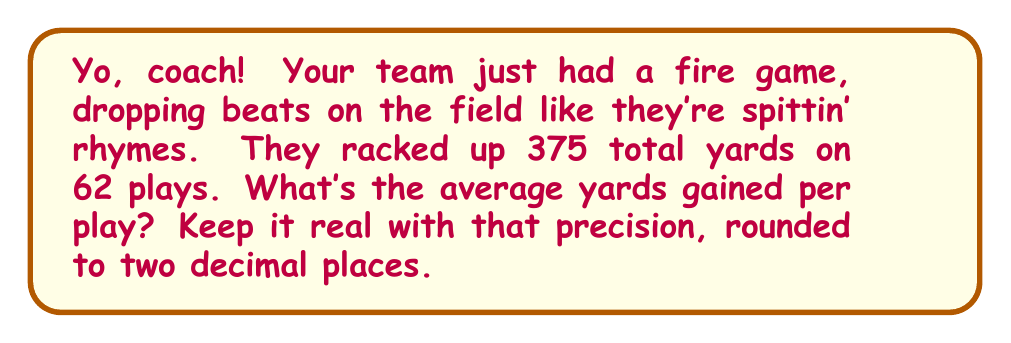Can you solve this math problem? Alright, let's break this down like we're analyzing a fresh track:

1) We've got two key stats here:
   - Total yards gained: 375
   - Number of plays: 62

2) To find the average yards per play, we need to divide the total yards by the number of plays. In mathematical terms:

   $$ \text{Average yards per play} = \frac{\text{Total yards}}{\text{Number of plays}} $$

3) Let's plug in our numbers:

   $$ \text{Average yards per play} = \frac{375}{62} $$

4) Now, let's do the division:

   $$ \frac{375}{62} \approx 6.0483870967741935 $$

5) The question asks for the answer rounded to two decimal places. To do this, we look at the third decimal place. If it's 5 or greater, we round up; if it's less than 5, we round down. In this case, the third decimal is 4, so we round down.

Therefore, rounded to two decimal places, the average is 6.05 yards per play.
Answer: $6.05$ yards per play 